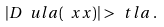Convert formula to latex. <formula><loc_0><loc_0><loc_500><loc_500>| D \ u l a ( \ x x ) | > \ t l a \, .</formula> 